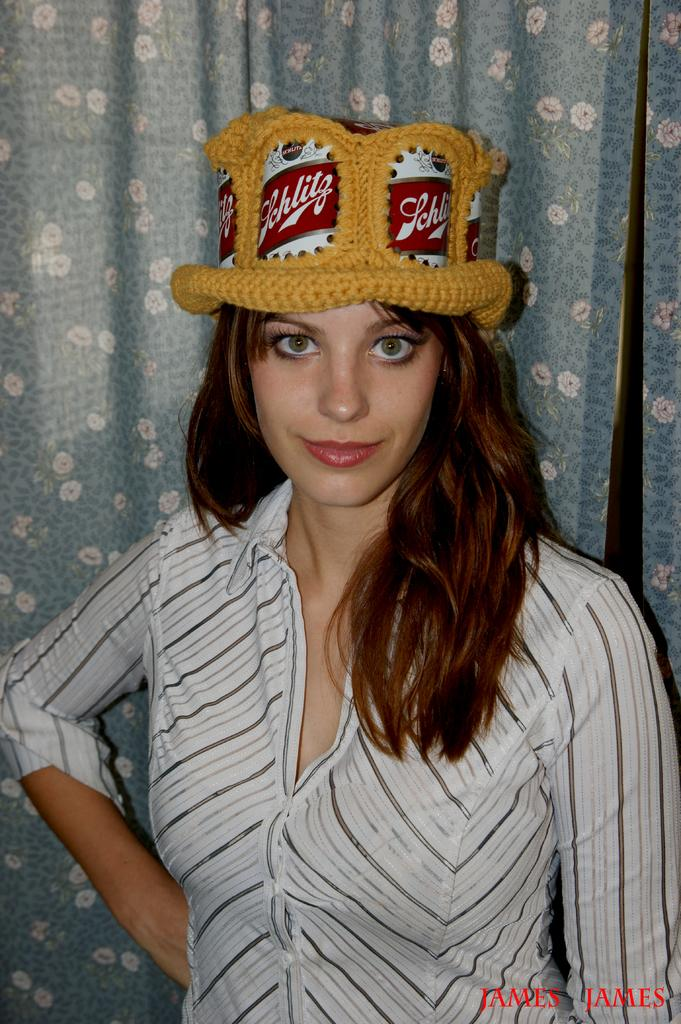Who is present in the image? There is a woman in the image. What is the woman wearing on her head? The woman is wearing a hat. What is the woman's facial expression in the image? The woman is smiling. What can be seen in the background of the image? There is a curtain in the background of the image. What type of design can be seen on the twig in the image? There is no twig present in the image, so it is not possible to determine the design on a twig. 